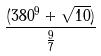Convert formula to latex. <formula><loc_0><loc_0><loc_500><loc_500>\frac { ( 3 8 0 ^ { 9 } + \sqrt { 1 0 } ) } { \frac { 9 } { 7 } }</formula> 